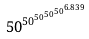Convert formula to latex. <formula><loc_0><loc_0><loc_500><loc_500>5 0 ^ { 5 0 ^ { 5 0 ^ { 5 0 ^ { 5 0 ^ { 6 . 8 3 9 } } } } }</formula> 